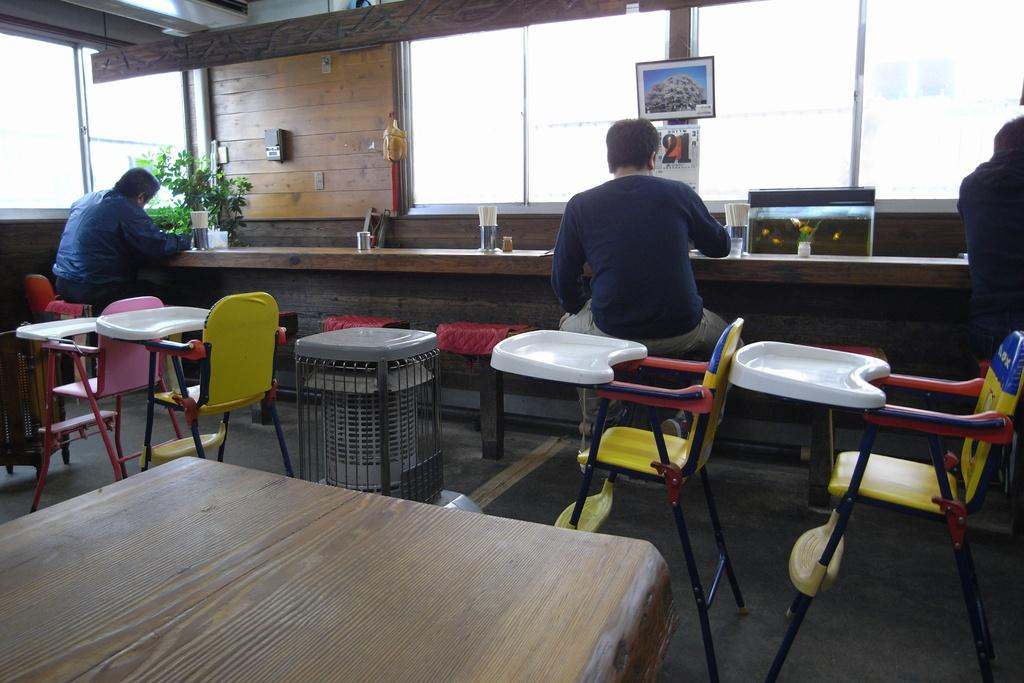How many people are in the image? There are three persons in the image. What are the persons doing in the image? The persons are sitting on chairs and doing something. What type of furniture is present in the image? There are chairs and a wooden table in the image. Where is the nest located in the image? There is no nest present in the image. Can you see a rabbit in the image? There is no rabbit present in the image. 